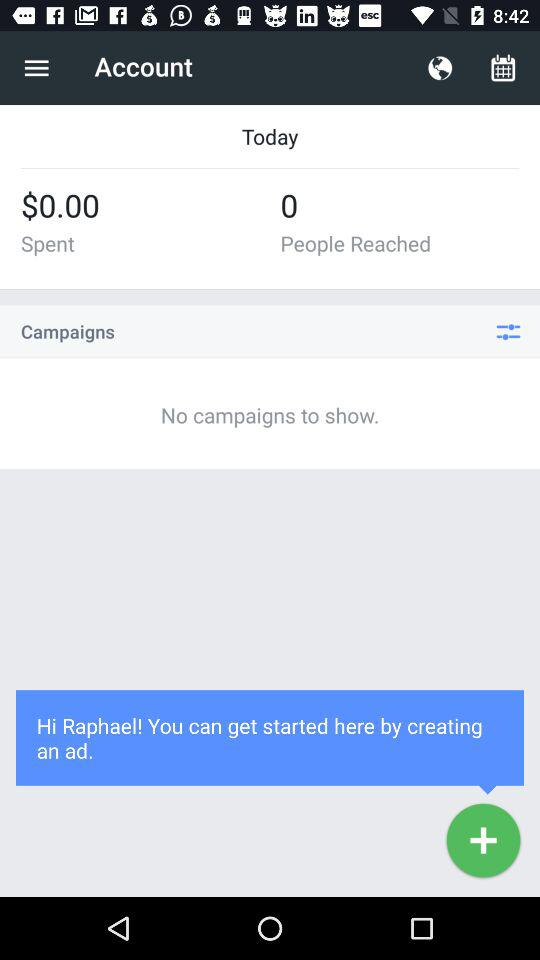What is the user name? The user name is Raphael. 